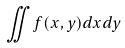<formula> <loc_0><loc_0><loc_500><loc_500>\iint f ( x , y ) d x d y</formula> 